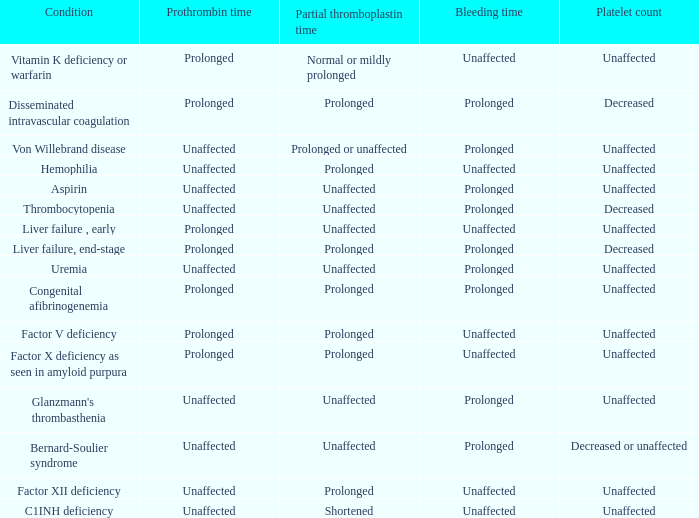What platelet count is associated with a bernard-soulier syndrome condition? Decreased or unaffected. 